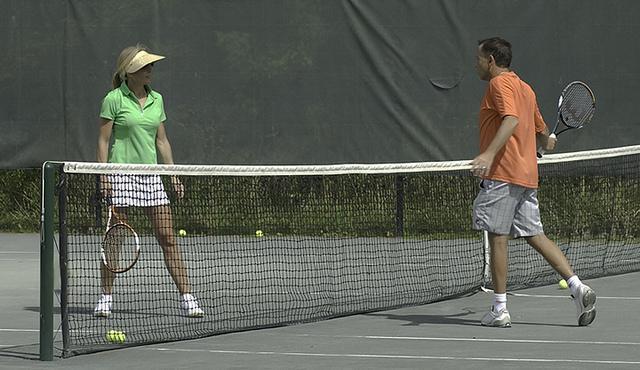How many balls can you count?
Give a very brief answer. 4. How many people can be seen?
Give a very brief answer. 2. How many apples are being peeled?
Give a very brief answer. 0. 